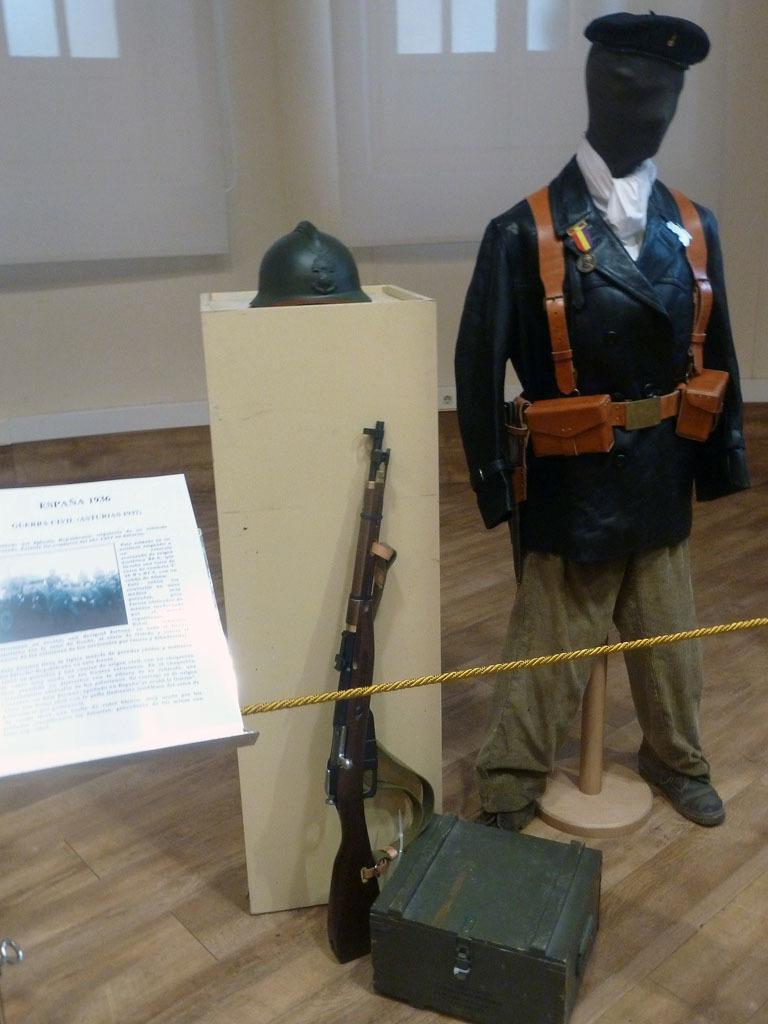Describe this image in one or two sentences. In this image we can see a mannequin with uniform, there is a helmet on the stand, a gun and a box on the floor, there is a board with text and image and there is a wall with windows in the background. 